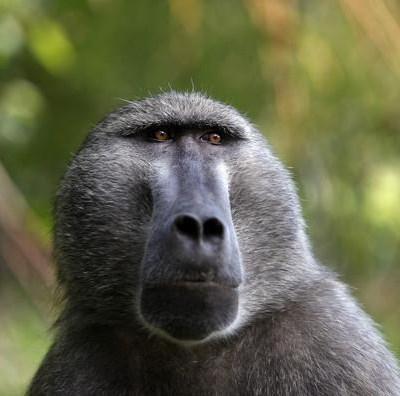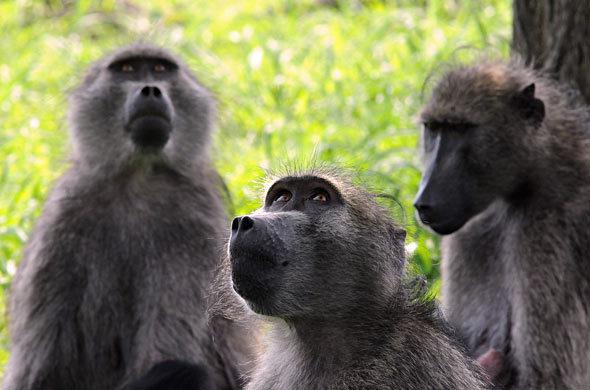The first image is the image on the left, the second image is the image on the right. Assess this claim about the two images: "A baby baboon is clinging to an adult baboon walking on all fours in one image, and each image contains at least one baby baboon.". Correct or not? Answer yes or no. No. The first image is the image on the left, the second image is the image on the right. Given the left and right images, does the statement "The right image contains at least two monkeys." hold true? Answer yes or no. Yes. 